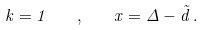<formula> <loc_0><loc_0><loc_500><loc_500>k = 1 \quad , \quad x = \Delta - \tilde { d } \, .</formula> 